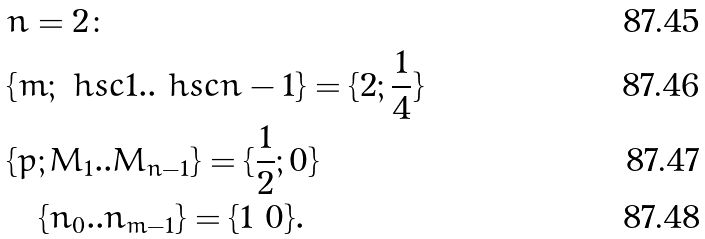Convert formula to latex. <formula><loc_0><loc_0><loc_500><loc_500>& n = 2 \colon \\ & \{ m ; \ h s c { 1 } . . \ h s c { n - 1 } \} = \{ 2 ; \frac { 1 } { 4 } \} \\ & \{ p ; M _ { 1 } . . M _ { n - 1 } \} = \{ \frac { 1 } { 2 } ; 0 \} \\ & \quad \{ n _ { 0 } . . n _ { m - 1 } \} = \{ 1 \ 0 \} .</formula> 